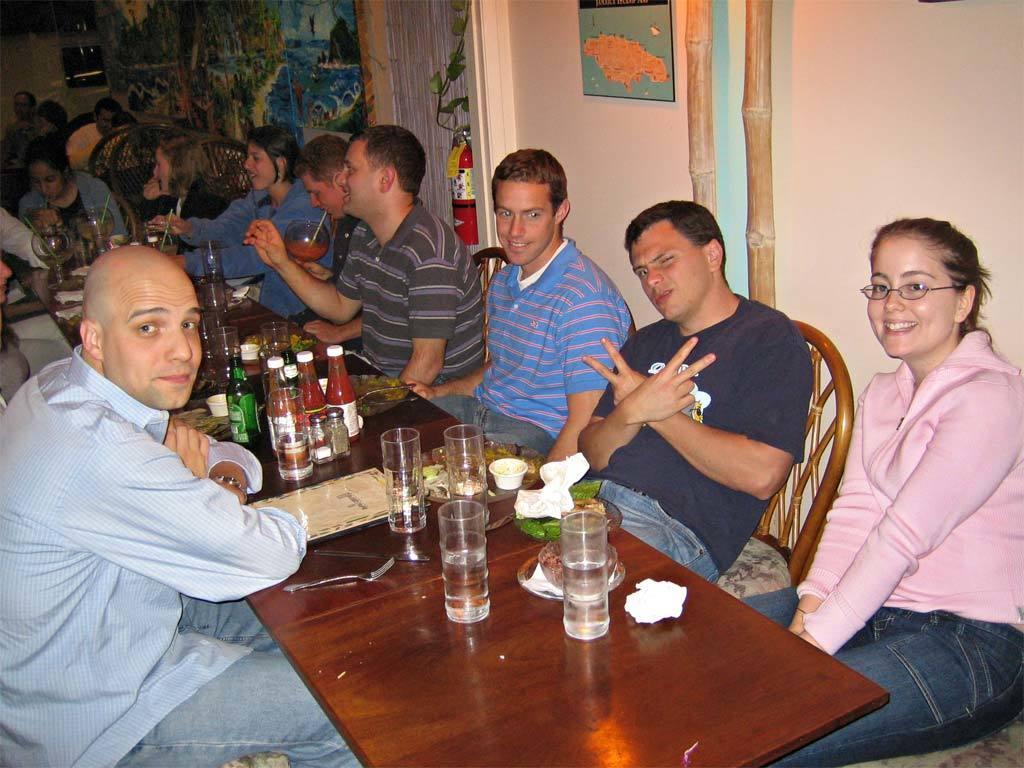Could you give a brief overview of what you see in this image? I can in this image a group of people are sitting in front of a table. On the table we have few glasses, bottles and other objects on it. I can also see there is a wall, door, fire extinguisher and other objects in the background. 